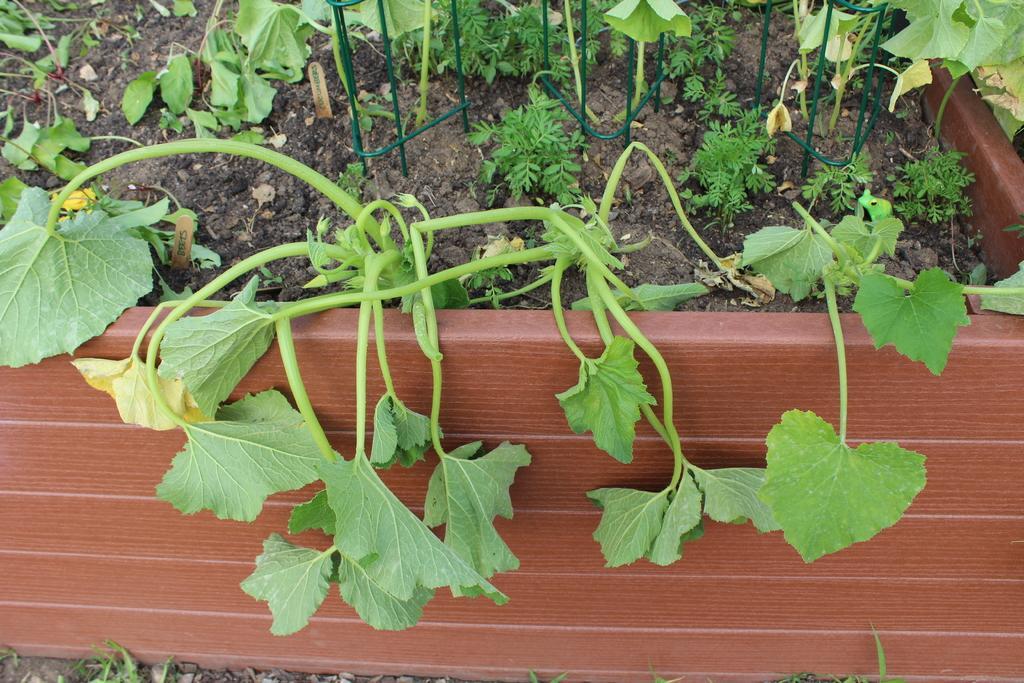Can you describe this image briefly? This is the picture of different types of plants and we can see a few plants planted in a pot which is in red color. 